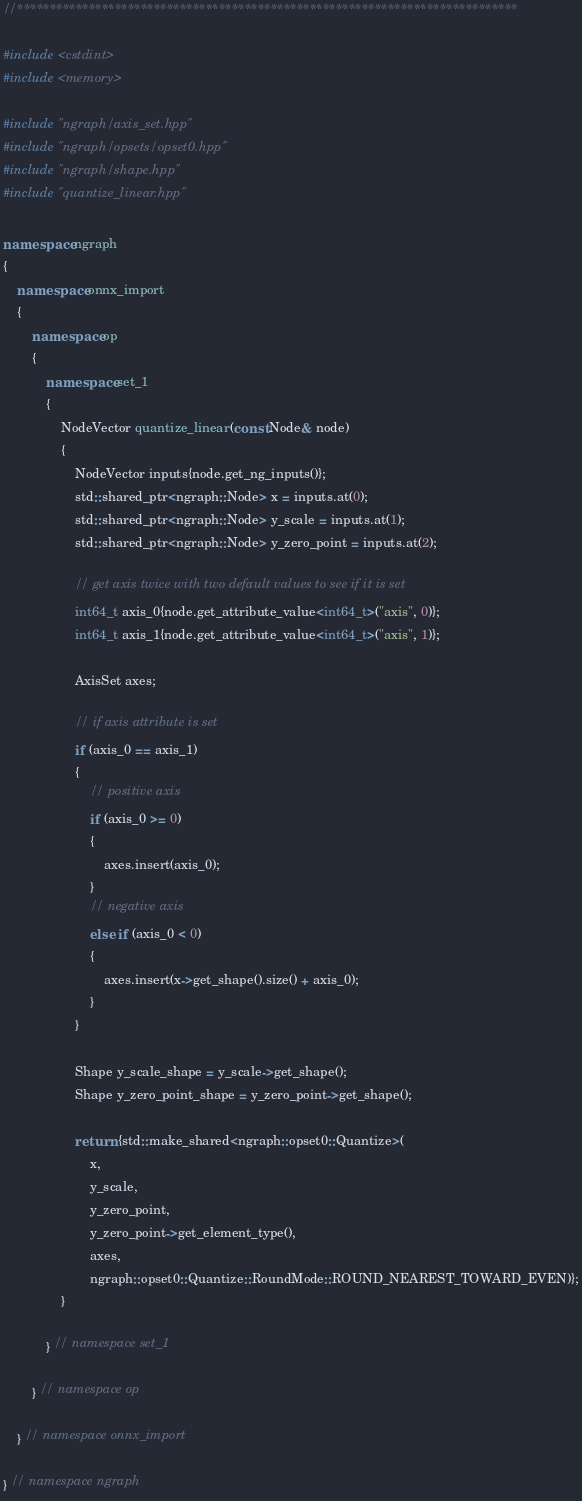Convert code to text. <code><loc_0><loc_0><loc_500><loc_500><_C++_>//*****************************************************************************

#include <cstdint>
#include <memory>

#include "ngraph/axis_set.hpp"
#include "ngraph/opsets/opset0.hpp"
#include "ngraph/shape.hpp"
#include "quantize_linear.hpp"

namespace ngraph
{
    namespace onnx_import
    {
        namespace op
        {
            namespace set_1
            {
                NodeVector quantize_linear(const Node& node)
                {
                    NodeVector inputs{node.get_ng_inputs()};
                    std::shared_ptr<ngraph::Node> x = inputs.at(0);
                    std::shared_ptr<ngraph::Node> y_scale = inputs.at(1);
                    std::shared_ptr<ngraph::Node> y_zero_point = inputs.at(2);

                    // get axis twice with two default values to see if it is set
                    int64_t axis_0{node.get_attribute_value<int64_t>("axis", 0)};
                    int64_t axis_1{node.get_attribute_value<int64_t>("axis", 1)};

                    AxisSet axes;

                    // if axis attribute is set
                    if (axis_0 == axis_1)
                    {
                        // positive axis
                        if (axis_0 >= 0)
                        {
                            axes.insert(axis_0);
                        }
                        // negative axis
                        else if (axis_0 < 0)
                        {
                            axes.insert(x->get_shape().size() + axis_0);
                        }
                    }

                    Shape y_scale_shape = y_scale->get_shape();
                    Shape y_zero_point_shape = y_zero_point->get_shape();

                    return {std::make_shared<ngraph::opset0::Quantize>(
                        x,
                        y_scale,
                        y_zero_point,
                        y_zero_point->get_element_type(),
                        axes,
                        ngraph::opset0::Quantize::RoundMode::ROUND_NEAREST_TOWARD_EVEN)};
                }

            } // namespace set_1

        } // namespace op

    } // namespace onnx_import

} // namespace ngraph
</code> 